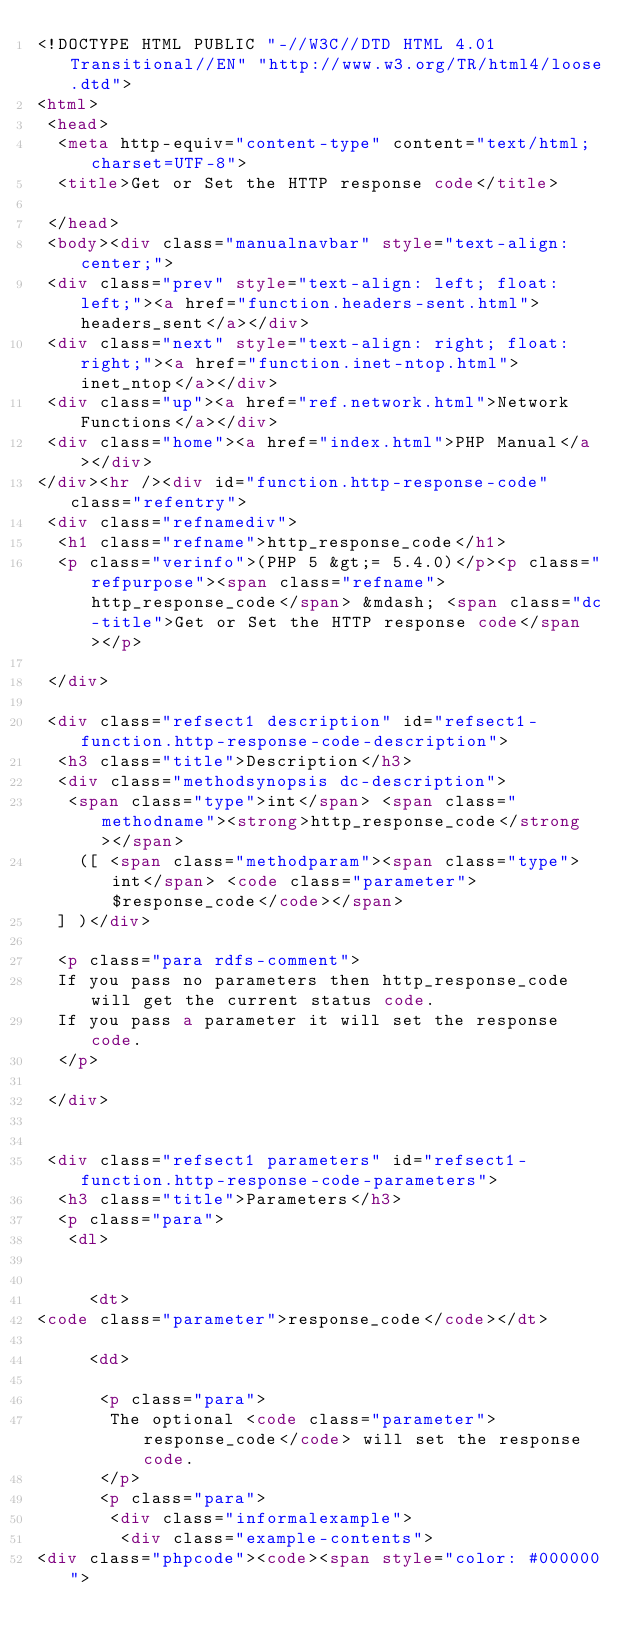Convert code to text. <code><loc_0><loc_0><loc_500><loc_500><_HTML_><!DOCTYPE HTML PUBLIC "-//W3C//DTD HTML 4.01 Transitional//EN" "http://www.w3.org/TR/html4/loose.dtd">
<html>
 <head>
  <meta http-equiv="content-type" content="text/html; charset=UTF-8">
  <title>Get or Set the HTTP response code</title>

 </head>
 <body><div class="manualnavbar" style="text-align: center;">
 <div class="prev" style="text-align: left; float: left;"><a href="function.headers-sent.html">headers_sent</a></div>
 <div class="next" style="text-align: right; float: right;"><a href="function.inet-ntop.html">inet_ntop</a></div>
 <div class="up"><a href="ref.network.html">Network Functions</a></div>
 <div class="home"><a href="index.html">PHP Manual</a></div>
</div><hr /><div id="function.http-response-code" class="refentry">
 <div class="refnamediv">
  <h1 class="refname">http_response_code</h1>
  <p class="verinfo">(PHP 5 &gt;= 5.4.0)</p><p class="refpurpose"><span class="refname">http_response_code</span> &mdash; <span class="dc-title">Get or Set the HTTP response code</span></p>

 </div>

 <div class="refsect1 description" id="refsect1-function.http-response-code-description">
  <h3 class="title">Description</h3>
  <div class="methodsynopsis dc-description">
   <span class="type">int</span> <span class="methodname"><strong>http_response_code</strong></span>
    ([ <span class="methodparam"><span class="type">int</span> <code class="parameter">$response_code</code></span>
  ] )</div>

  <p class="para rdfs-comment">
  If you pass no parameters then http_response_code will get the current status code.
  If you pass a parameter it will set the response code.
  </p>

 </div>


 <div class="refsect1 parameters" id="refsect1-function.http-response-code-parameters">
  <h3 class="title">Parameters</h3>
  <p class="para">
   <dl>

    
     <dt>
<code class="parameter">response_code</code></dt>

     <dd>

      <p class="para">
       The optional <code class="parameter">response_code</code> will set the response code.
      </p>
      <p class="para">
       <div class="informalexample">
        <div class="example-contents">
<div class="phpcode"><code><span style="color: #000000"></code> 